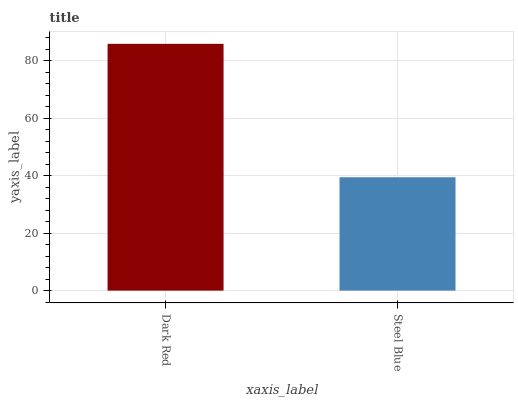Is Steel Blue the minimum?
Answer yes or no. Yes. Is Dark Red the maximum?
Answer yes or no. Yes. Is Steel Blue the maximum?
Answer yes or no. No. Is Dark Red greater than Steel Blue?
Answer yes or no. Yes. Is Steel Blue less than Dark Red?
Answer yes or no. Yes. Is Steel Blue greater than Dark Red?
Answer yes or no. No. Is Dark Red less than Steel Blue?
Answer yes or no. No. Is Dark Red the high median?
Answer yes or no. Yes. Is Steel Blue the low median?
Answer yes or no. Yes. Is Steel Blue the high median?
Answer yes or no. No. Is Dark Red the low median?
Answer yes or no. No. 